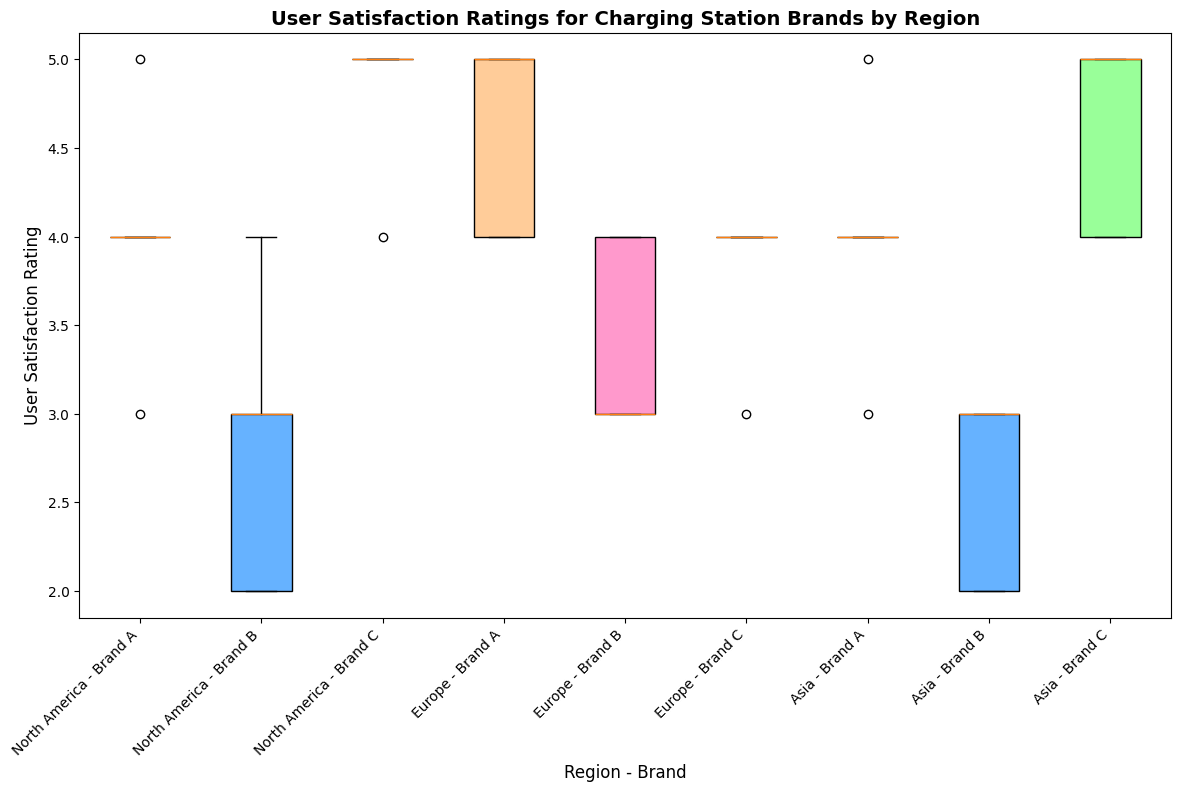Which brand in North America has the highest median user satisfaction rating? To find the brand with the highest median in North America, identify the middle value of the ratings within the boxes for each brand in that region. The middle line in the box for Brand C is the highest among Brand A, Brand B, and Brand C in North America.
Answer: Brand C How do the interquartile ranges (IQR) of Brand B in North America and Asia compare? The IQR is the distance between the first (Q1) and third quartiles (Q3), seen as the length of the box. For Brand B, North America's box is shorter than Asia's, indicating a smaller IQR. This means North America has less variability in user satisfaction ratings for Brand B than Asia.
Answer: North America's IQR is smaller than Asia's Which region-Brand combination shows the highest variability in user satisfaction ratings? Variability in a box plot is indicated by the length of the whiskers and the height of the box. By observing all combinations, Brand A in North America shows the highest spread, with long whiskers and a tall box, implying higher variability.
Answer: Brand A in North America Are there any regions where two brands have the same median user satisfaction rating? To determine if two brands have the same median, look at the middle line in each box plot within a region. In Europe, both Brand B and Brand C have a median line at 4, indicating they share the same median rating.
Answer: Yes, in Europe Which brand in Asia has the lowest user satisfaction ratings? Locate the bottom whiskers in the box plots for brands in Asia. Brand B has its lowest point at 2, which is lower than the minimums for Brand A and Brand C.
Answer: Brand B What's the range of user satisfaction ratings for Brand A in Asia? The range is the difference between the maximum and minimum values. For Brand A in Asia, the top whisker is at 5, and the bottom whisker is at 3. Therefore, the range is 5 - 3.
Answer: 2 What is the median user satisfaction rating for Brand C in Asia? Locate the middle line in the box plot for Brand C in Asia. The median line is at 5, which is the median user satisfaction rating.
Answer: 5 How does the spread of user satisfaction ratings for Brand A in Europe compare to Brand A in North America? The spread can be seen by the length of the whiskers and height of the boxes. Brand A in Europe has a shorter box and whiskers compared to Brand A in North America, indicating lower variability in Europe.
Answer: Europe has lower variability than North America Which combination of region and brand has the lowest upper quartile (Q3) for user satisfaction ratings? The upper quartile is the top of the box. Compare the heights of the tops of all boxes. Brand B in Asia has the lowest top of the box at a value of 3.
Answer: Brand B in Asia 